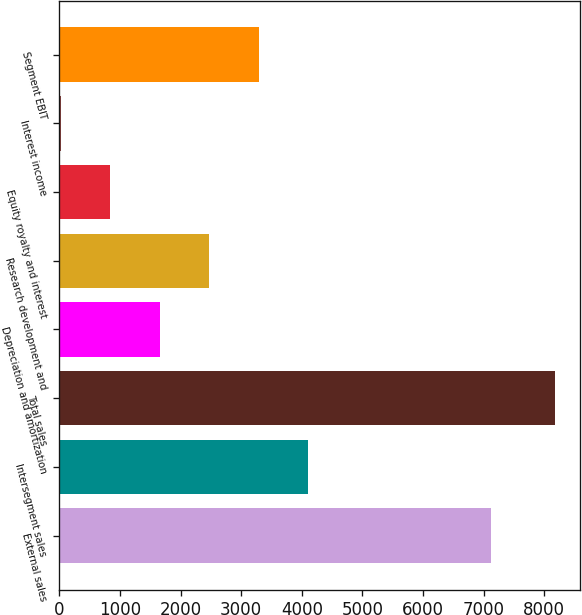Convert chart to OTSL. <chart><loc_0><loc_0><loc_500><loc_500><bar_chart><fcel>External sales<fcel>Intersegment sales<fcel>Total sales<fcel>Depreciation and amortization<fcel>Research development and<fcel>Equity royalty and interest<fcel>Interest income<fcel>Segment EBIT<nl><fcel>7129<fcel>4104<fcel>8182<fcel>1657.2<fcel>2472.8<fcel>841.6<fcel>26<fcel>3288.4<nl></chart> 